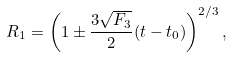<formula> <loc_0><loc_0><loc_500><loc_500>R _ { 1 } = \left ( 1 \pm \frac { 3 \sqrt { F _ { 3 } } } { 2 } ( t - t _ { 0 } ) \right ) ^ { 2 / 3 } ,</formula> 